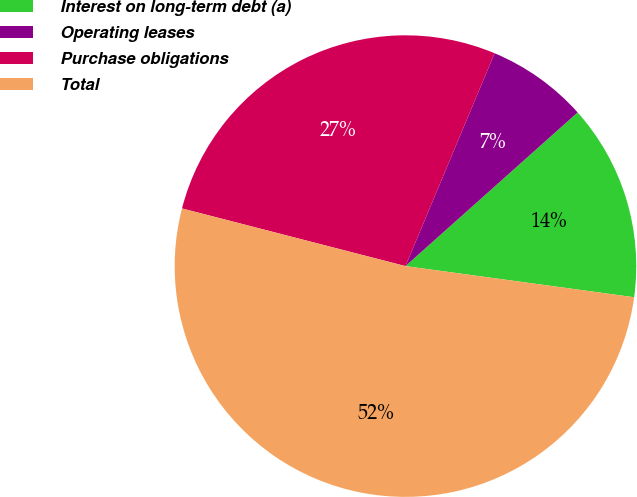<chart> <loc_0><loc_0><loc_500><loc_500><pie_chart><fcel>Interest on long-term debt (a)<fcel>Operating leases<fcel>Purchase obligations<fcel>Total<nl><fcel>13.75%<fcel>7.09%<fcel>27.29%<fcel>51.86%<nl></chart> 